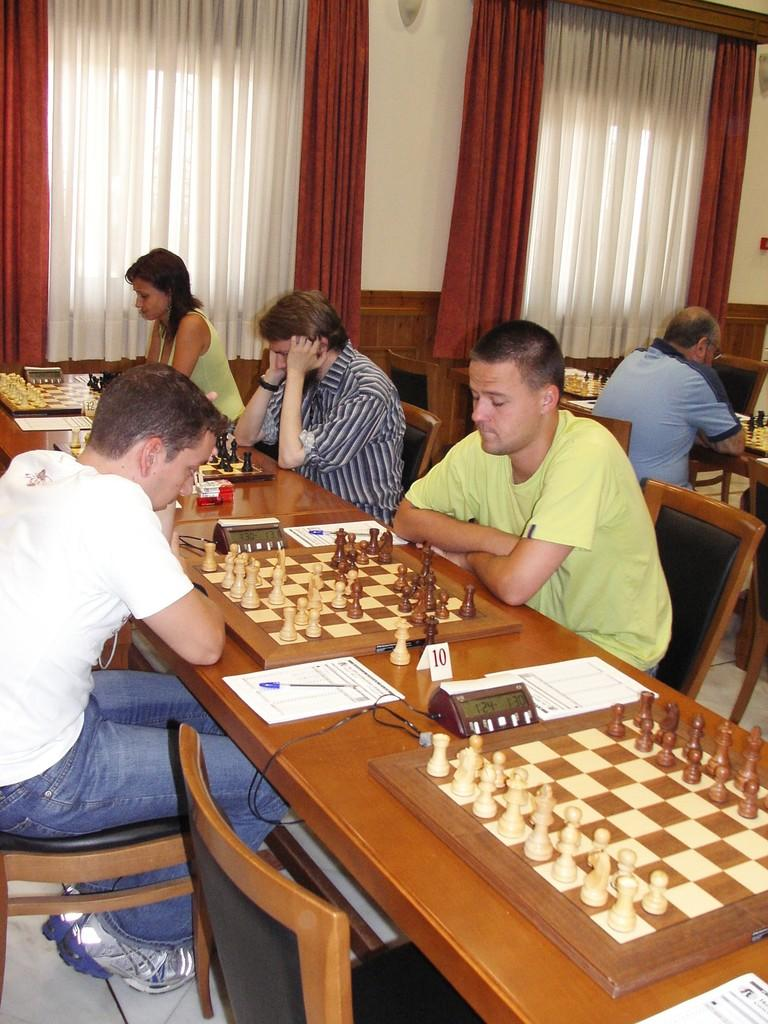How many people are present in the image? There are 5 people in the image. What are the people doing in the image? The people are sitting on chairs. What can be seen on the table in the image? There is a chess board on a table. What is visible in the background of the image? There is a wall and curtains in the background of the image. What is the name of the ghost sitting on the chair in the image? There is no ghost present in the image; it features 5 people sitting on chairs. Are any of the people wearing stockings in the image? The provided facts do not mention any specific clothing items, so it cannot be determined if any of the people are wearing stockings. 